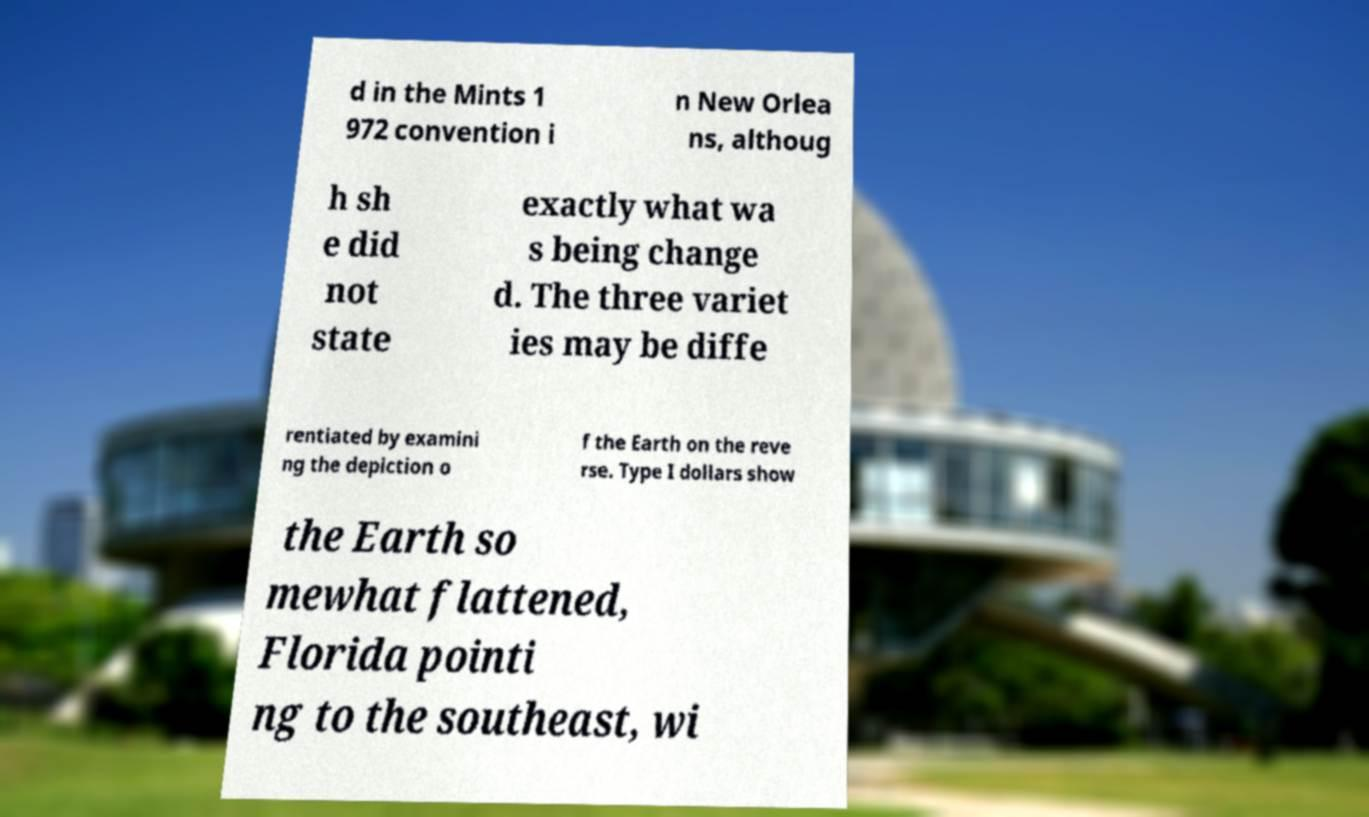Can you accurately transcribe the text from the provided image for me? d in the Mints 1 972 convention i n New Orlea ns, althoug h sh e did not state exactly what wa s being change d. The three variet ies may be diffe rentiated by examini ng the depiction o f the Earth on the reve rse. Type I dollars show the Earth so mewhat flattened, Florida pointi ng to the southeast, wi 